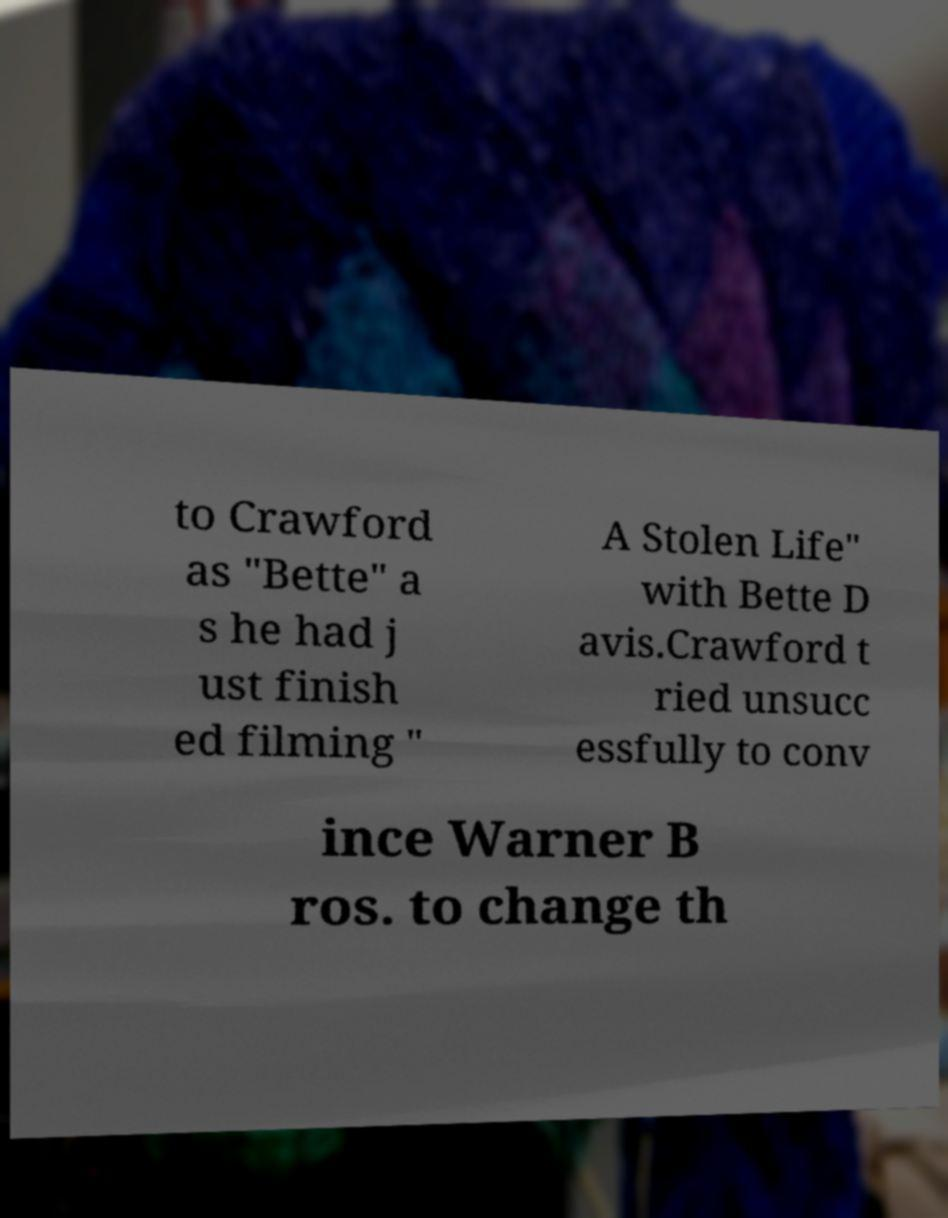For documentation purposes, I need the text within this image transcribed. Could you provide that? to Crawford as "Bette" a s he had j ust finish ed filming " A Stolen Life" with Bette D avis.Crawford t ried unsucc essfully to conv ince Warner B ros. to change th 